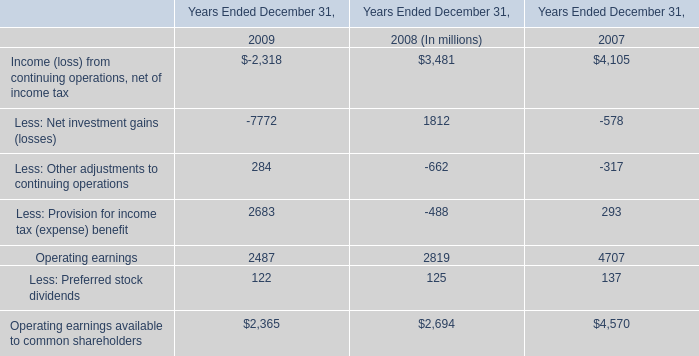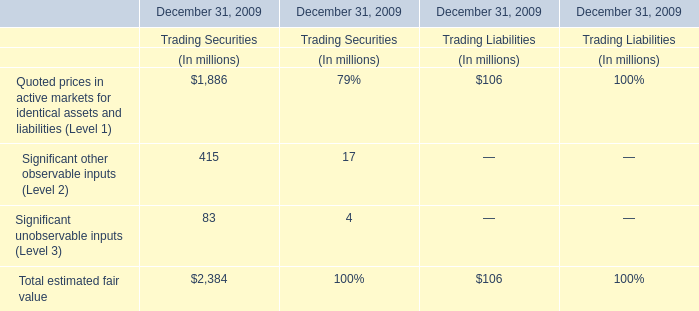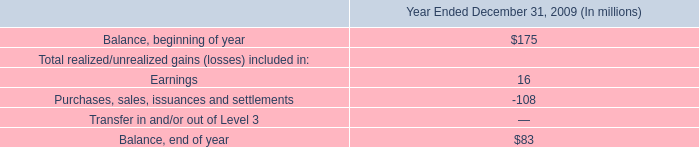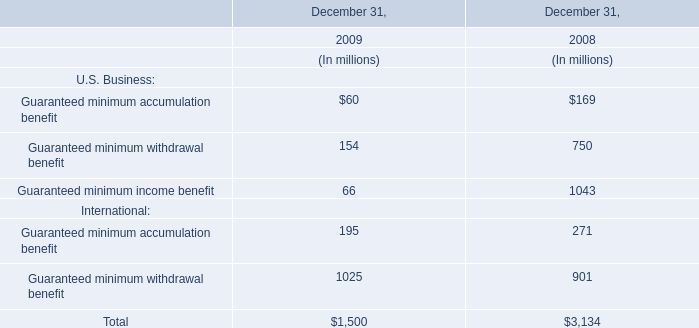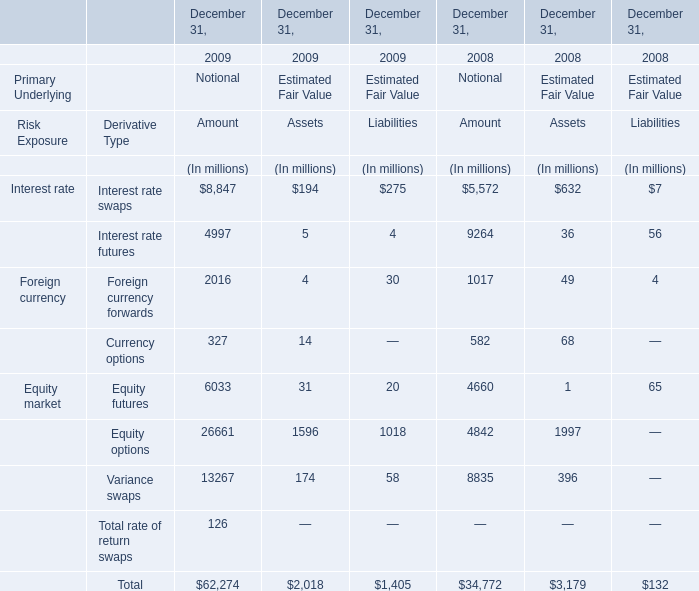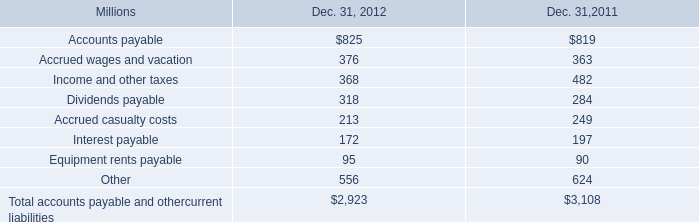What will Guaranteed minimum withdrawal benefit in international reach in 2010 if it continues to grow at its current rate? (in million) 
Computations: ((((1025 - 901) / 901) + 1) * 1025)
Answer: 1166.06548. 